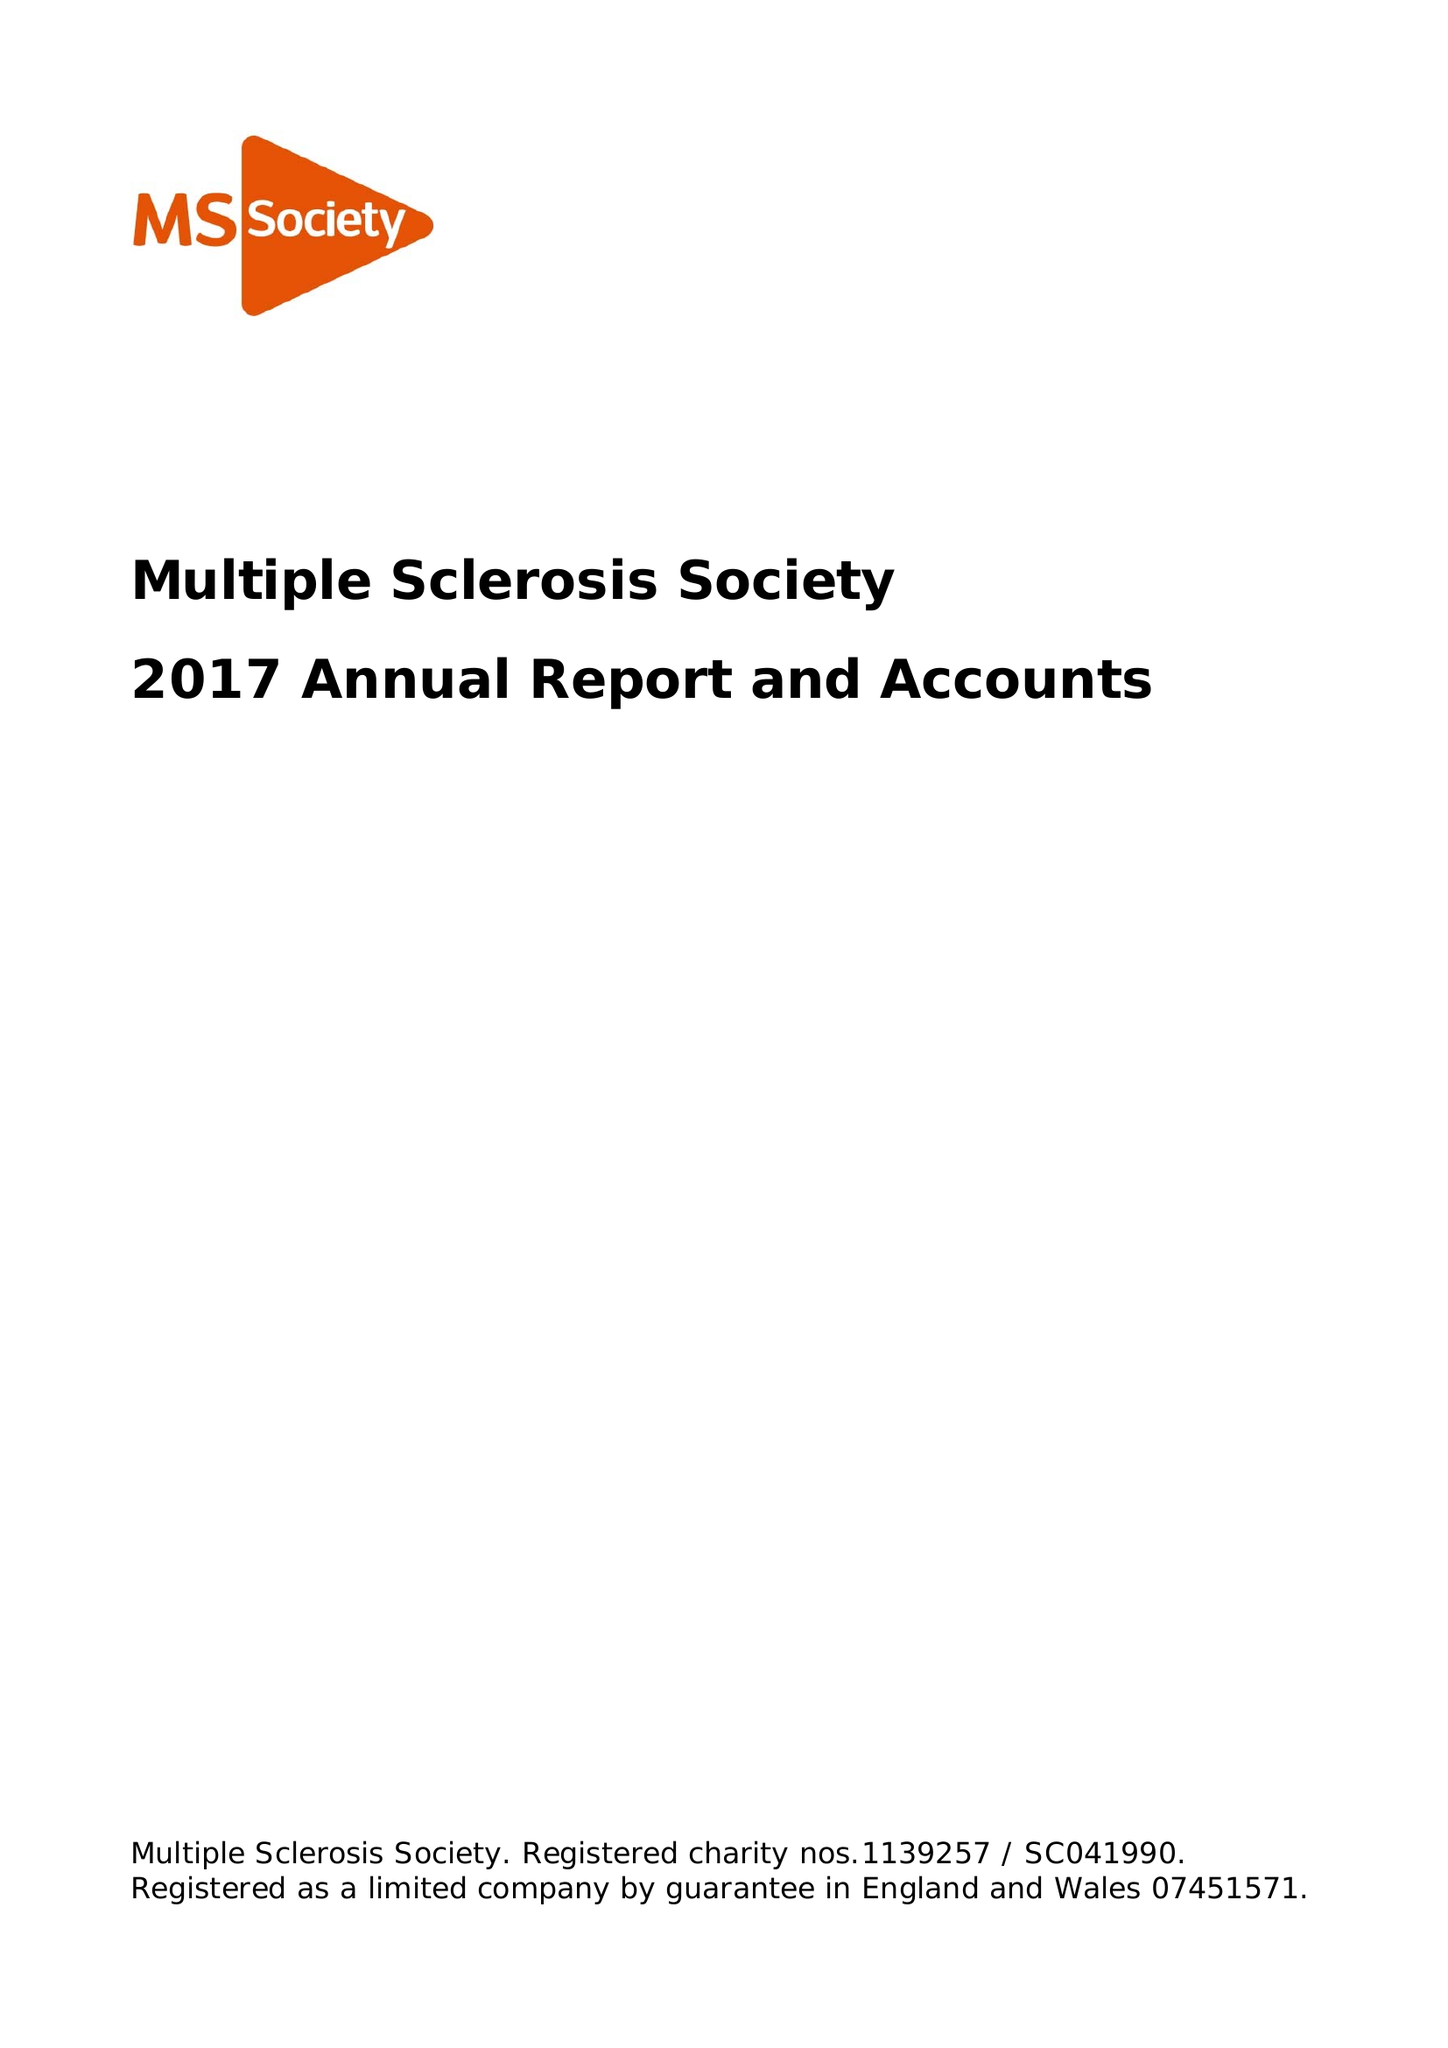What is the value for the charity_number?
Answer the question using a single word or phrase. 1139257 